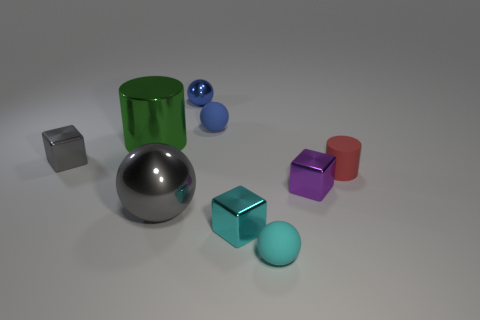Subtract all cubes. How many objects are left? 6 Add 8 small gray things. How many small gray things are left? 9 Add 1 cyan blocks. How many cyan blocks exist? 2 Subtract 0 red spheres. How many objects are left? 9 Subtract all tiny rubber cylinders. Subtract all small cyan objects. How many objects are left? 6 